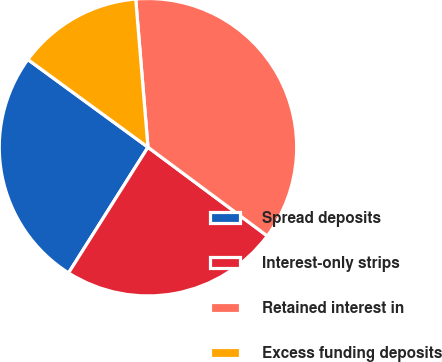<chart> <loc_0><loc_0><loc_500><loc_500><pie_chart><fcel>Spread deposits<fcel>Interest-only strips<fcel>Retained interest in<fcel>Excess funding deposits<nl><fcel>26.07%<fcel>23.79%<fcel>36.49%<fcel>13.65%<nl></chart> 